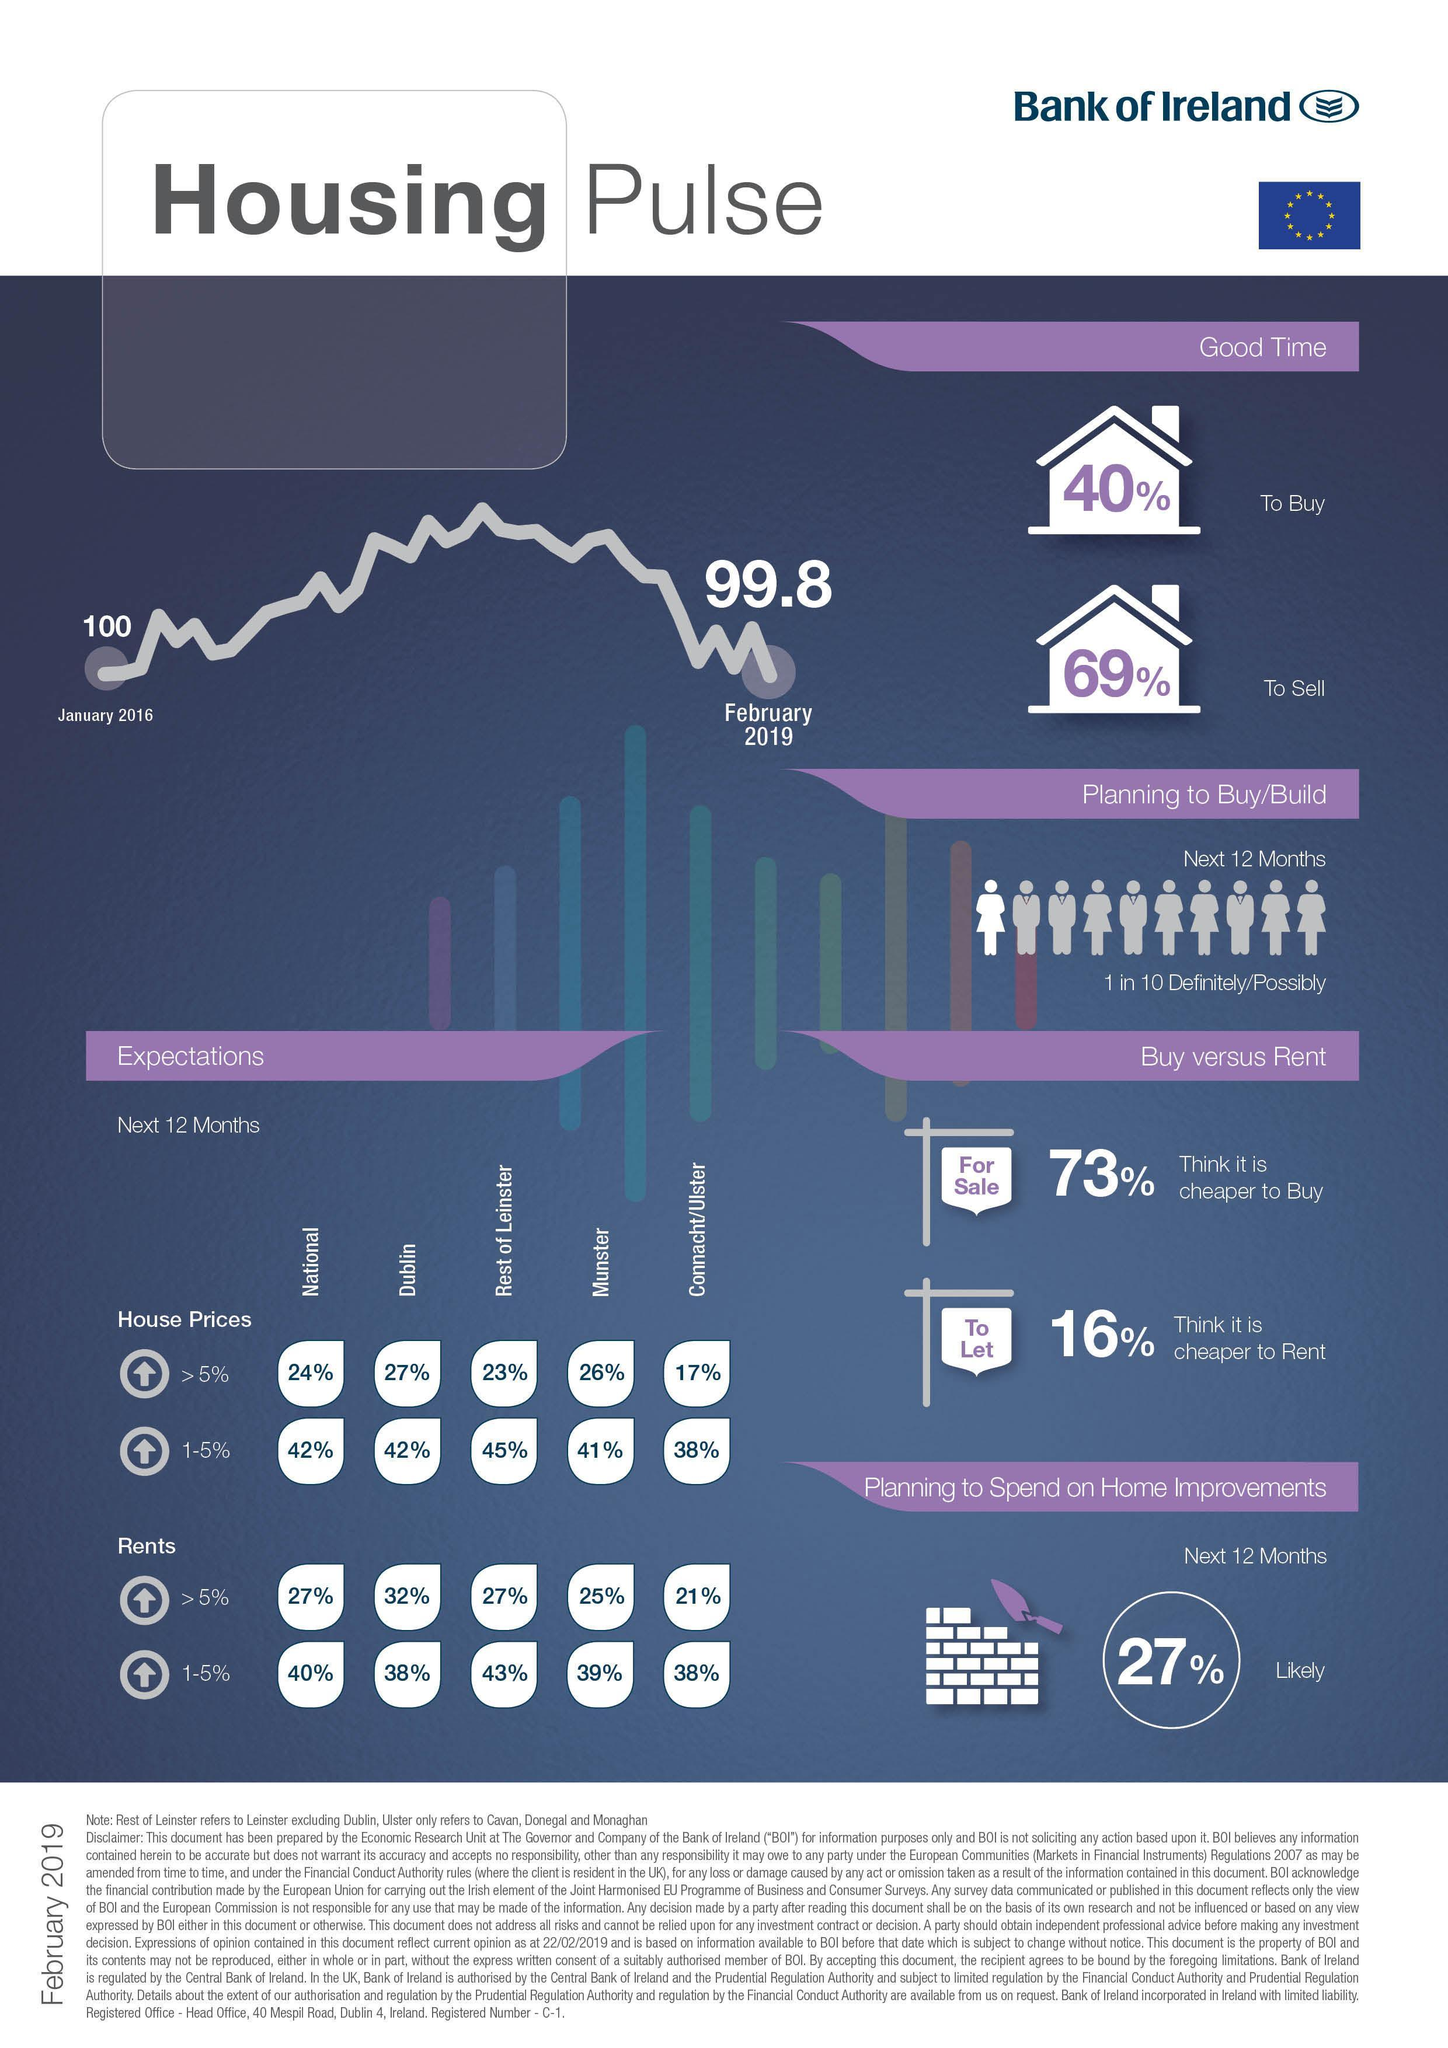What % of people definite plan to buy / build house in the next 12 months
Answer the question with a short phrase. 10 What is written on the banner beside 73% for sale What % of rental price will rise by 1-5% in Rest of Leinster 43% What % of house prices will rise by >5% in Munster 26% What is the % difference in people who think it is a good time to buy against people who think it is a good time to sell 29 Has there been a rise or decline in the housing pulse decline what is written on the banner beside 16% to let What % of rental price will rise by 1-5% in Dublin 38% What % of house prices will rise by >5% in Dublin 27% 